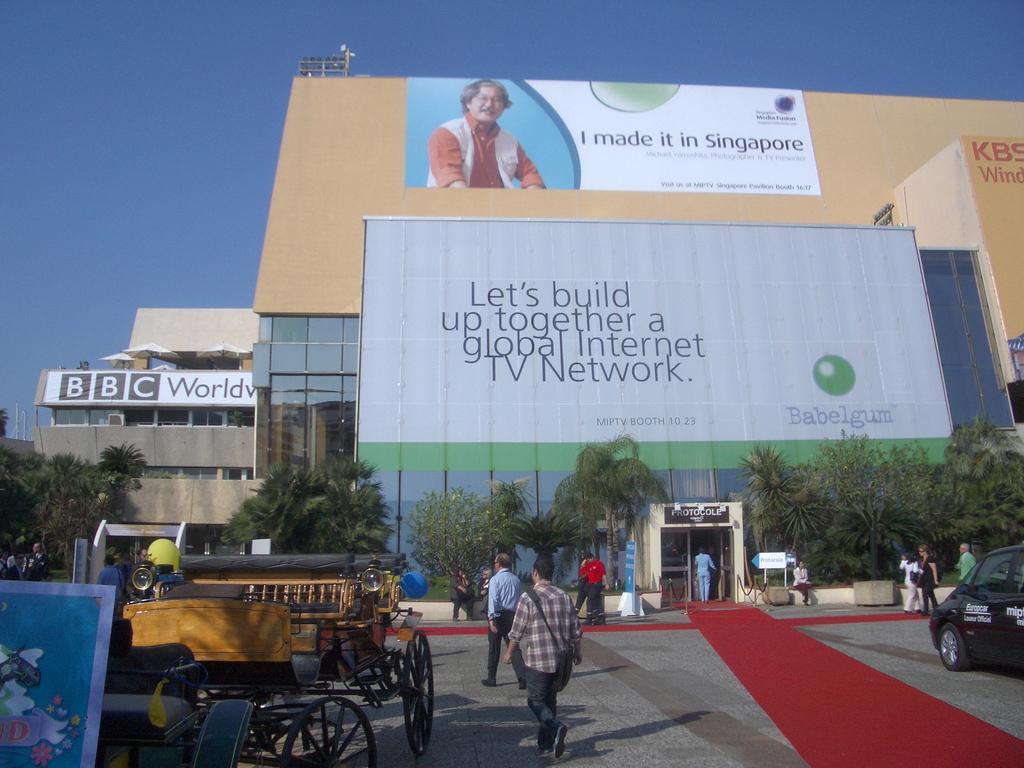Can you describe this image briefly? In this image in the front there is a cart which is on the road and there are persons walking. On the right side there is a car with some text written on it which is black in colour and in the center there is a mat on the floor which is red in colour, and there are persons sitting and standing and walking. In the background there is a building with some text written on it and there are trees. 